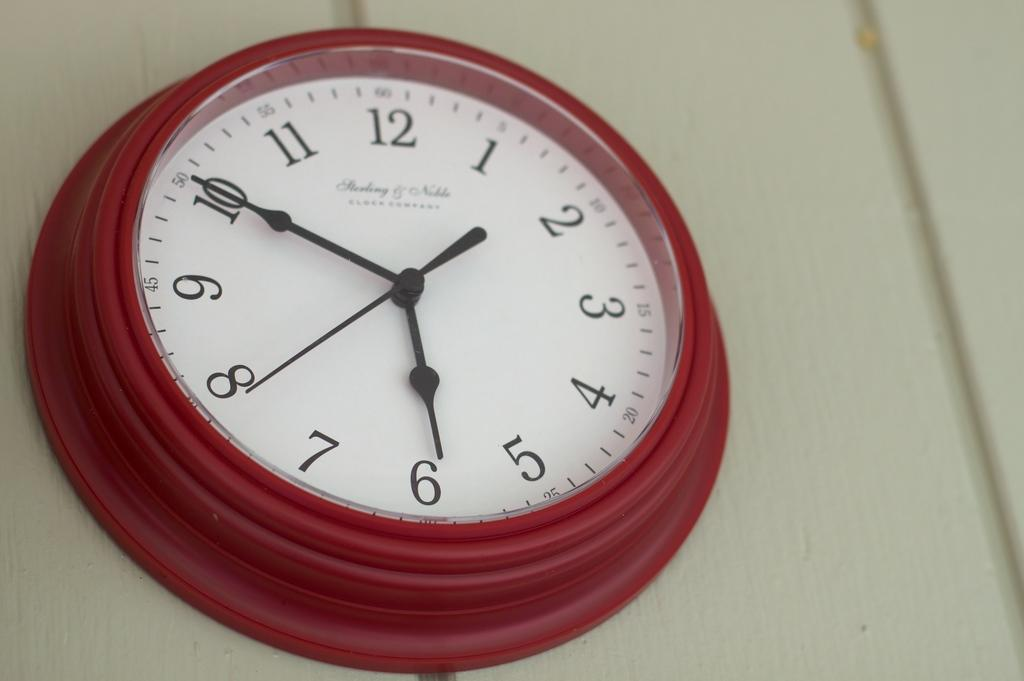Provide a one-sentence caption for the provided image. A red clock on a white wall shows that the time is 5:50. 